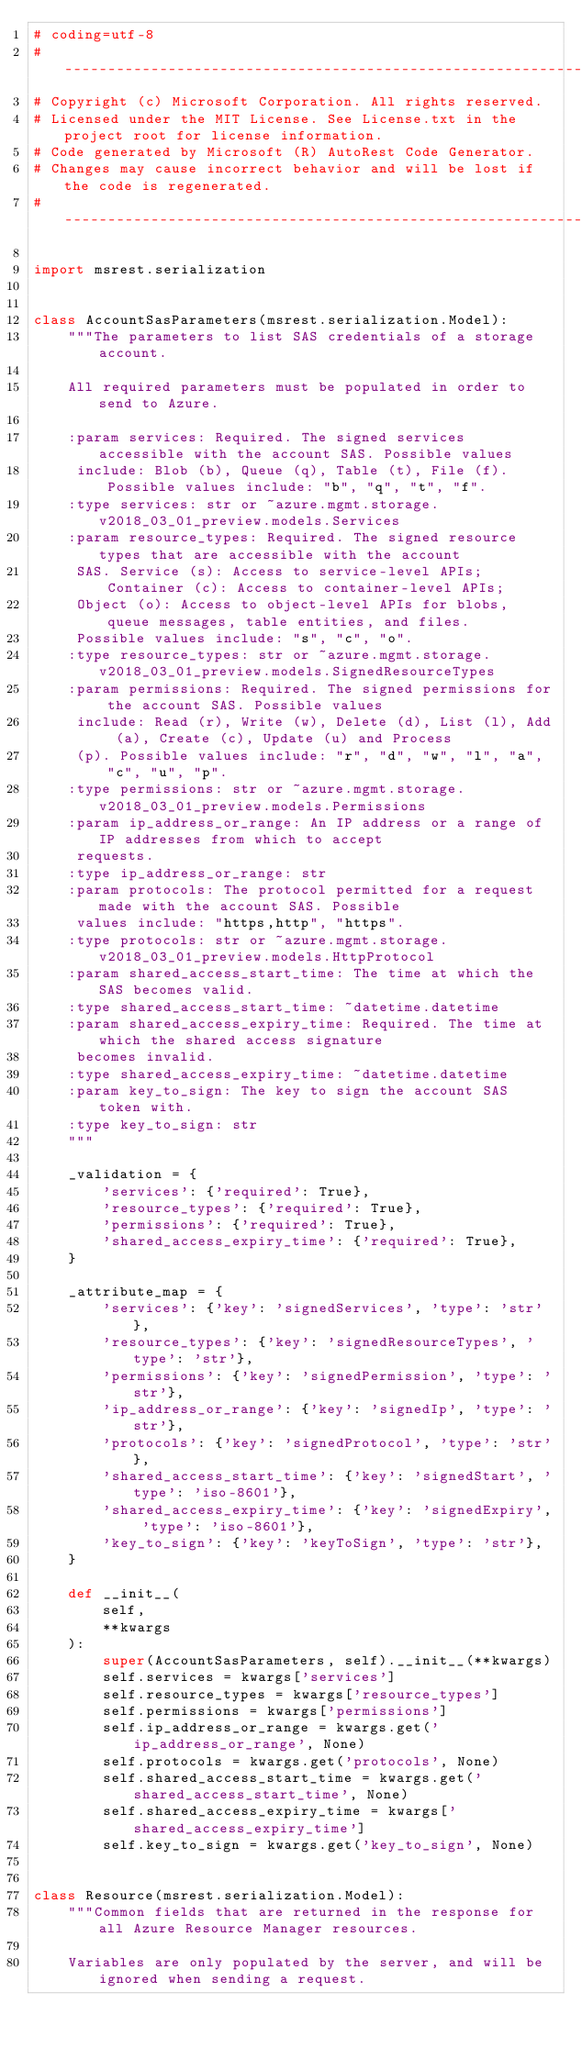<code> <loc_0><loc_0><loc_500><loc_500><_Python_># coding=utf-8
# --------------------------------------------------------------------------
# Copyright (c) Microsoft Corporation. All rights reserved.
# Licensed under the MIT License. See License.txt in the project root for license information.
# Code generated by Microsoft (R) AutoRest Code Generator.
# Changes may cause incorrect behavior and will be lost if the code is regenerated.
# --------------------------------------------------------------------------

import msrest.serialization


class AccountSasParameters(msrest.serialization.Model):
    """The parameters to list SAS credentials of a storage account.

    All required parameters must be populated in order to send to Azure.

    :param services: Required. The signed services accessible with the account SAS. Possible values
     include: Blob (b), Queue (q), Table (t), File (f). Possible values include: "b", "q", "t", "f".
    :type services: str or ~azure.mgmt.storage.v2018_03_01_preview.models.Services
    :param resource_types: Required. The signed resource types that are accessible with the account
     SAS. Service (s): Access to service-level APIs; Container (c): Access to container-level APIs;
     Object (o): Access to object-level APIs for blobs, queue messages, table entities, and files.
     Possible values include: "s", "c", "o".
    :type resource_types: str or ~azure.mgmt.storage.v2018_03_01_preview.models.SignedResourceTypes
    :param permissions: Required. The signed permissions for the account SAS. Possible values
     include: Read (r), Write (w), Delete (d), List (l), Add (a), Create (c), Update (u) and Process
     (p). Possible values include: "r", "d", "w", "l", "a", "c", "u", "p".
    :type permissions: str or ~azure.mgmt.storage.v2018_03_01_preview.models.Permissions
    :param ip_address_or_range: An IP address or a range of IP addresses from which to accept
     requests.
    :type ip_address_or_range: str
    :param protocols: The protocol permitted for a request made with the account SAS. Possible
     values include: "https,http", "https".
    :type protocols: str or ~azure.mgmt.storage.v2018_03_01_preview.models.HttpProtocol
    :param shared_access_start_time: The time at which the SAS becomes valid.
    :type shared_access_start_time: ~datetime.datetime
    :param shared_access_expiry_time: Required. The time at which the shared access signature
     becomes invalid.
    :type shared_access_expiry_time: ~datetime.datetime
    :param key_to_sign: The key to sign the account SAS token with.
    :type key_to_sign: str
    """

    _validation = {
        'services': {'required': True},
        'resource_types': {'required': True},
        'permissions': {'required': True},
        'shared_access_expiry_time': {'required': True},
    }

    _attribute_map = {
        'services': {'key': 'signedServices', 'type': 'str'},
        'resource_types': {'key': 'signedResourceTypes', 'type': 'str'},
        'permissions': {'key': 'signedPermission', 'type': 'str'},
        'ip_address_or_range': {'key': 'signedIp', 'type': 'str'},
        'protocols': {'key': 'signedProtocol', 'type': 'str'},
        'shared_access_start_time': {'key': 'signedStart', 'type': 'iso-8601'},
        'shared_access_expiry_time': {'key': 'signedExpiry', 'type': 'iso-8601'},
        'key_to_sign': {'key': 'keyToSign', 'type': 'str'},
    }

    def __init__(
        self,
        **kwargs
    ):
        super(AccountSasParameters, self).__init__(**kwargs)
        self.services = kwargs['services']
        self.resource_types = kwargs['resource_types']
        self.permissions = kwargs['permissions']
        self.ip_address_or_range = kwargs.get('ip_address_or_range', None)
        self.protocols = kwargs.get('protocols', None)
        self.shared_access_start_time = kwargs.get('shared_access_start_time', None)
        self.shared_access_expiry_time = kwargs['shared_access_expiry_time']
        self.key_to_sign = kwargs.get('key_to_sign', None)


class Resource(msrest.serialization.Model):
    """Common fields that are returned in the response for all Azure Resource Manager resources.

    Variables are only populated by the server, and will be ignored when sending a request.
</code> 